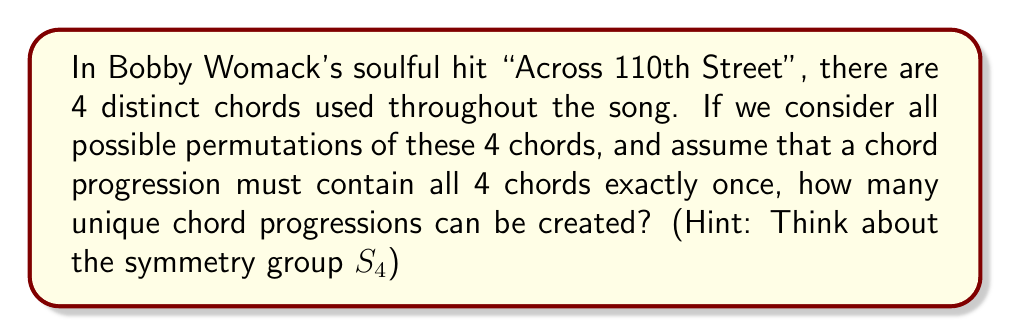Could you help me with this problem? To solve this problem, we can use concepts from group theory, specifically the symmetric group $S_4$.

1) First, let's understand what the question is asking:
   - We have 4 distinct chords
   - Each chord progression must use all 4 chords exactly once
   - We need to find all possible permutations of these 4 chords

2) This scenario is perfectly represented by the symmetric group $S_4$, which contains all permutations of 4 distinct elements.

3) In group theory, the order of a symmetric group $S_n$ is given by $n!$ (n factorial).

4) Therefore, the number of elements in $S_4$ is:

   $$|S_4| = 4! = 4 \times 3 \times 2 \times 1 = 24$$

5) Each element in $S_4$ represents a unique permutation of the 4 chords, which in turn represents a unique chord progression.

6) Thus, the number of distinct chord progressions possible is equal to the number of elements in $S_4$, which is 24.

This approach using group theory allows us to quickly determine the number of possibilities without having to list out each permutation manually.
Answer: 24 distinct chord progressions 